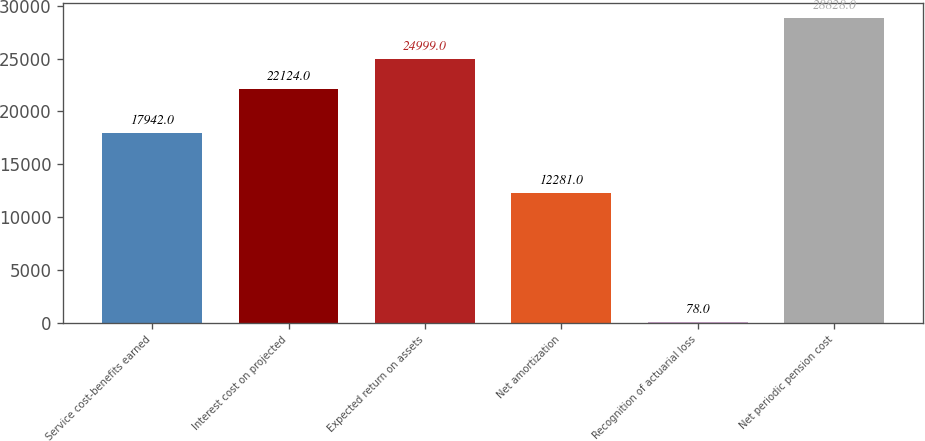Convert chart. <chart><loc_0><loc_0><loc_500><loc_500><bar_chart><fcel>Service cost-benefits earned<fcel>Interest cost on projected<fcel>Expected return on assets<fcel>Net amortization<fcel>Recognition of actuarial loss<fcel>Net periodic pension cost<nl><fcel>17942<fcel>22124<fcel>24999<fcel>12281<fcel>78<fcel>28828<nl></chart> 